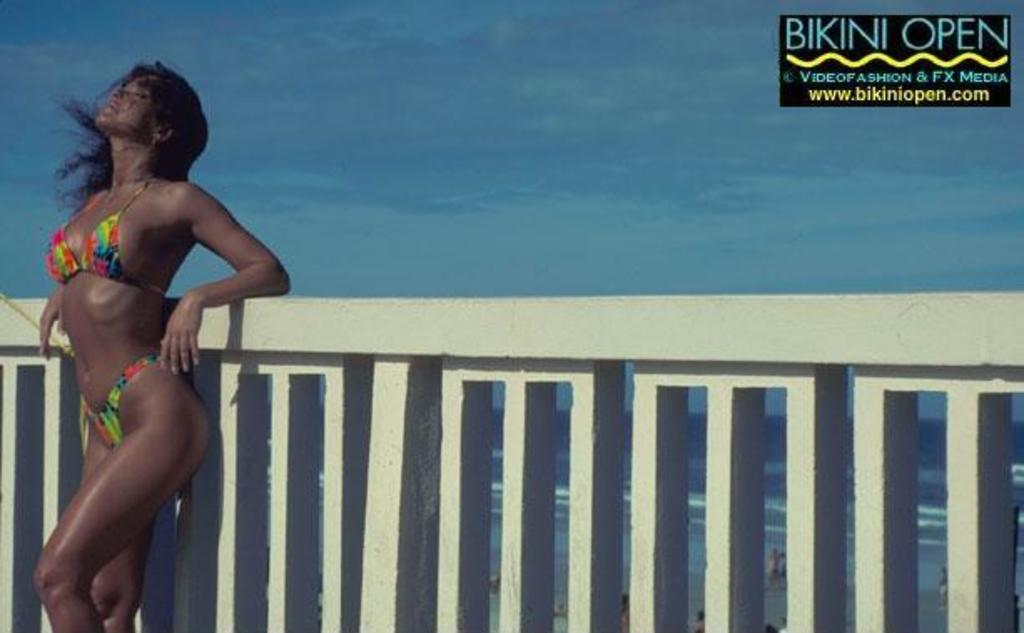Who is present in the image? There is a woman in the image. What is the woman doing in the image? The woman is standing at a fence. What can be seen in the background of the image? The sky is visible in the background of the image. What is the condition of the sky in the image? Clouds are present in the sky. What sea creatures can be seen swimming in the image? There is no sea or sea creatures present in the image; it features a woman standing at a fence with a cloudy sky in the background. 